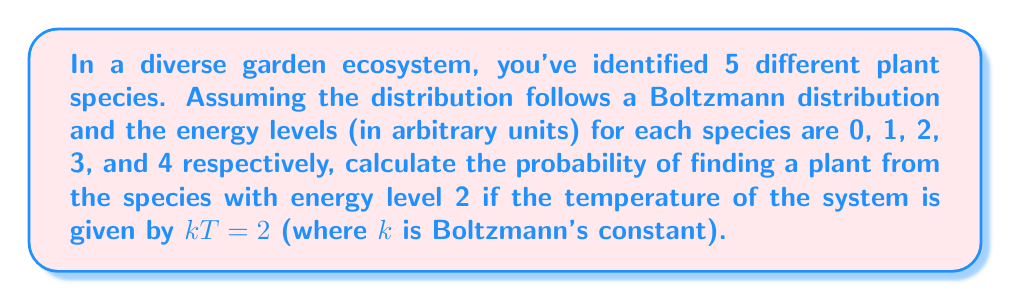Could you help me with this problem? To solve this problem, we'll use the Boltzmann distribution formula:

$$P_i = \frac{e^{-E_i/kT}}{\sum_{j=1}^N e^{-E_j/kT}}$$

Where:
$P_i$ is the probability of finding a particle in state $i$
$E_i$ is the energy of state $i$
$k$ is Boltzmann's constant
$T$ is temperature
$N$ is the total number of states

Step 1: Calculate the numerator for the species with energy level 2:
$$e^{-E_i/kT} = e^{-2/2} = e^{-1} \approx 0.3679$$

Step 2: Calculate the denominator (partition function):
$$\sum_{j=1}^N e^{-E_j/kT} = e^{-0/2} + e^{-1/2} + e^{-2/2} + e^{-3/2} + e^{-4/2}$$
$$= 1 + e^{-1/2} + e^{-1} + e^{-3/2} + e^{-2}$$
$$\approx 1 + 0.6065 + 0.3679 + 0.2231 + 0.1353$$
$$\approx 2.3328$$

Step 3: Calculate the probability:
$$P_2 = \frac{e^{-1}}{2.3328} \approx \frac{0.3679}{2.3328} \approx 0.1577$$

Therefore, the probability of finding a plant from the species with energy level 2 is approximately 0.1577 or 15.77%.
Answer: 0.1577 